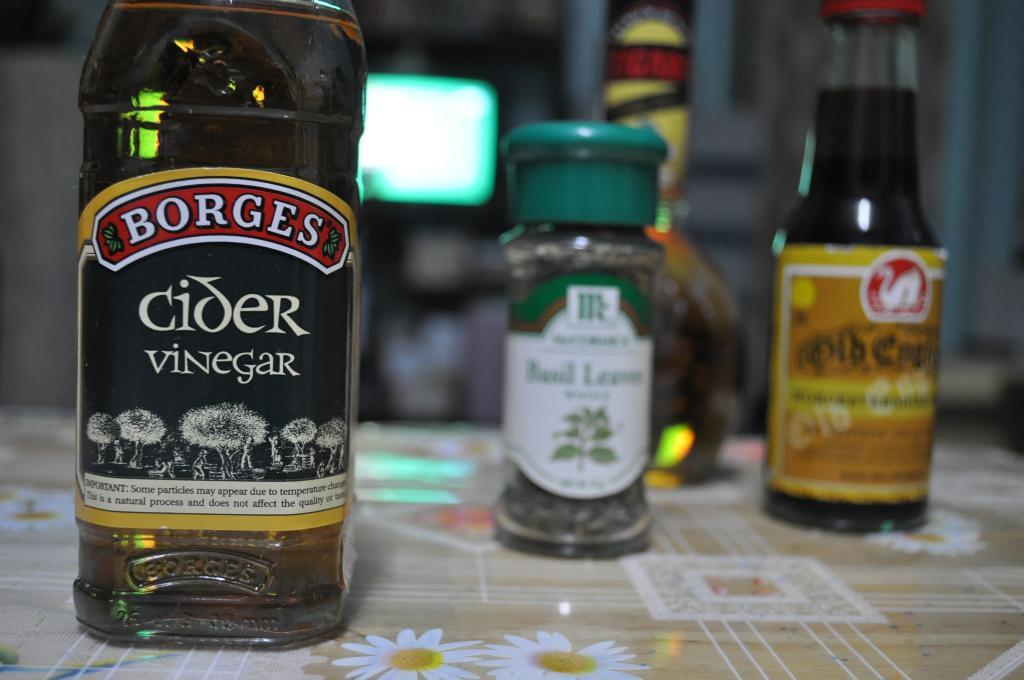What is the seasoning in the middle?
Provide a short and direct response. Basil. 